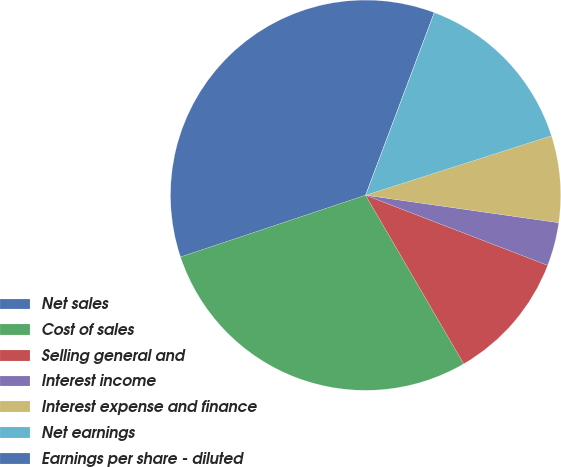Convert chart to OTSL. <chart><loc_0><loc_0><loc_500><loc_500><pie_chart><fcel>Net sales<fcel>Cost of sales<fcel>Selling general and<fcel>Interest income<fcel>Interest expense and finance<fcel>Net earnings<fcel>Earnings per share - diluted<nl><fcel>35.84%<fcel>28.26%<fcel>10.76%<fcel>3.6%<fcel>7.18%<fcel>14.34%<fcel>0.01%<nl></chart> 